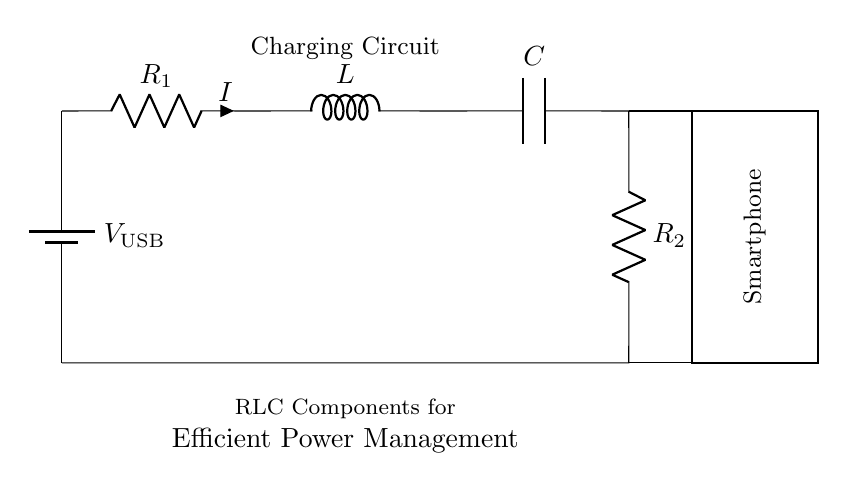What is the power source in this circuit? The power source is labeled as V_USB, which indicates it's a USB power supply.
Answer: USB What are the RLC components in the circuit? The RLC components are represented as a resistor (R), an inductor (L), and a capacitor (C).
Answer: Resistor, Inductor, Capacitor What is the total current flowing through the circuit? The current (I) is represented in the circuit and visually identified as flowing through the resistor R1 and into the circuit.
Answer: I Which component is closest to the smartphone? The capacitor is the component directly linked to the smartphone, indicated by the connection line.
Answer: Capacitor How many resistors are present in the circuit? There are two resistors present, R1 and R2, as shown in the diagram.
Answer: Two What function does the inductor serve in this circuit? The inductor helps to smooth out the current and manage power levels, creating a more stable charging process for the smartphone.
Answer: Smoothing Current What happens when one of the RLC elements fails in this circuit? If one of the RLC elements fails, it could disrupt the entire charging circuit, leading to inefficient power management or no charging.
Answer: Disruption 